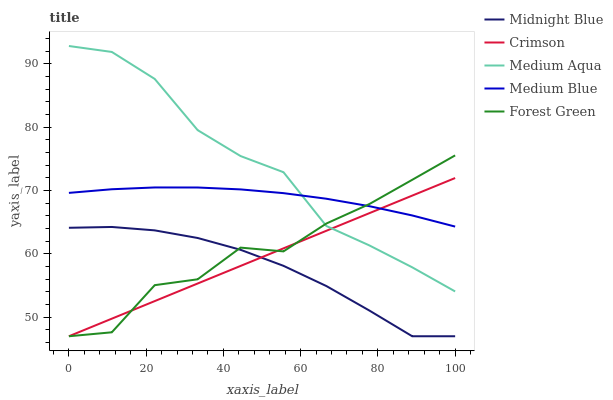Does Midnight Blue have the minimum area under the curve?
Answer yes or no. Yes. Does Medium Aqua have the maximum area under the curve?
Answer yes or no. Yes. Does Medium Blue have the minimum area under the curve?
Answer yes or no. No. Does Medium Blue have the maximum area under the curve?
Answer yes or no. No. Is Crimson the smoothest?
Answer yes or no. Yes. Is Forest Green the roughest?
Answer yes or no. Yes. Is Medium Blue the smoothest?
Answer yes or no. No. Is Medium Blue the roughest?
Answer yes or no. No. Does Crimson have the lowest value?
Answer yes or no. Yes. Does Medium Blue have the lowest value?
Answer yes or no. No. Does Medium Aqua have the highest value?
Answer yes or no. Yes. Does Medium Blue have the highest value?
Answer yes or no. No. Is Midnight Blue less than Medium Aqua?
Answer yes or no. Yes. Is Medium Aqua greater than Midnight Blue?
Answer yes or no. Yes. Does Crimson intersect Medium Aqua?
Answer yes or no. Yes. Is Crimson less than Medium Aqua?
Answer yes or no. No. Is Crimson greater than Medium Aqua?
Answer yes or no. No. Does Midnight Blue intersect Medium Aqua?
Answer yes or no. No. 